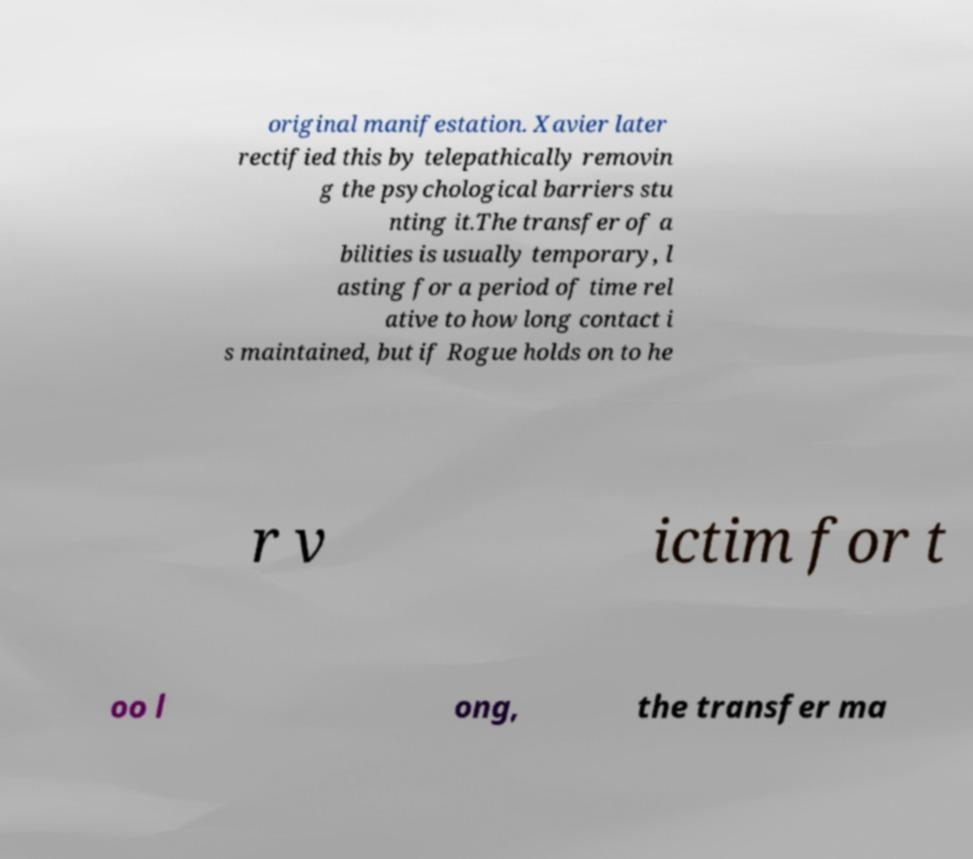For documentation purposes, I need the text within this image transcribed. Could you provide that? original manifestation. Xavier later rectified this by telepathically removin g the psychological barriers stu nting it.The transfer of a bilities is usually temporary, l asting for a period of time rel ative to how long contact i s maintained, but if Rogue holds on to he r v ictim for t oo l ong, the transfer ma 